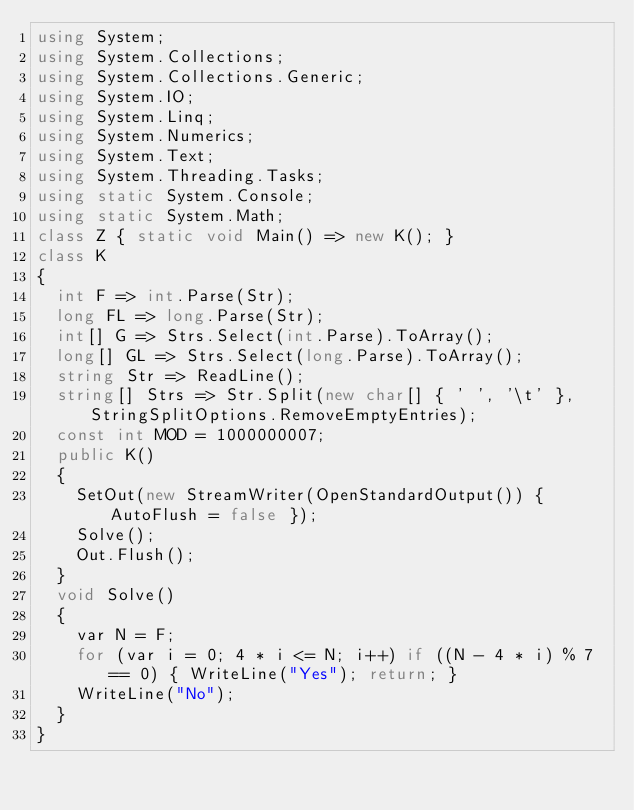<code> <loc_0><loc_0><loc_500><loc_500><_C#_>using System;
using System.Collections;
using System.Collections.Generic;
using System.IO;
using System.Linq;
using System.Numerics;
using System.Text;
using System.Threading.Tasks;
using static System.Console;
using static System.Math;
class Z { static void Main() => new K(); }
class K
{
	int F => int.Parse(Str);
	long FL => long.Parse(Str);
	int[] G => Strs.Select(int.Parse).ToArray();
	long[] GL => Strs.Select(long.Parse).ToArray();
	string Str => ReadLine();
	string[] Strs => Str.Split(new char[] { ' ', '\t' }, StringSplitOptions.RemoveEmptyEntries);
	const int MOD = 1000000007;
	public K()
	{
		SetOut(new StreamWriter(OpenStandardOutput()) { AutoFlush = false });
		Solve();
		Out.Flush();
	}
	void Solve()
	{
		var N = F;
		for (var i = 0; 4 * i <= N; i++) if ((N - 4 * i) % 7 == 0) { WriteLine("Yes"); return; }
		WriteLine("No");
	}
}
</code> 